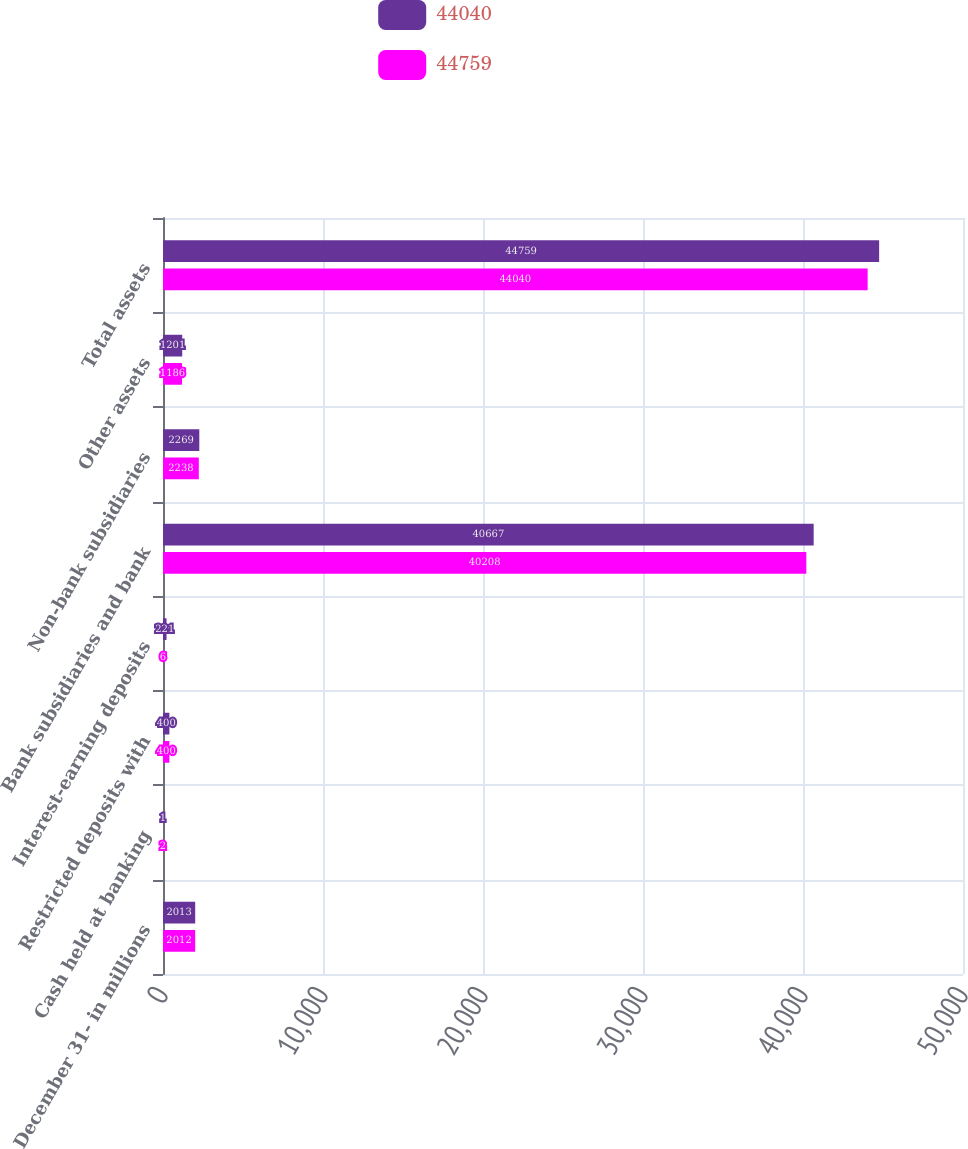Convert chart to OTSL. <chart><loc_0><loc_0><loc_500><loc_500><stacked_bar_chart><ecel><fcel>December 31- in millions<fcel>Cash held at banking<fcel>Restricted deposits with<fcel>Interest-earning deposits<fcel>Bank subsidiaries and bank<fcel>Non-bank subsidiaries<fcel>Other assets<fcel>Total assets<nl><fcel>44040<fcel>2013<fcel>1<fcel>400<fcel>221<fcel>40667<fcel>2269<fcel>1201<fcel>44759<nl><fcel>44759<fcel>2012<fcel>2<fcel>400<fcel>6<fcel>40208<fcel>2238<fcel>1186<fcel>44040<nl></chart> 